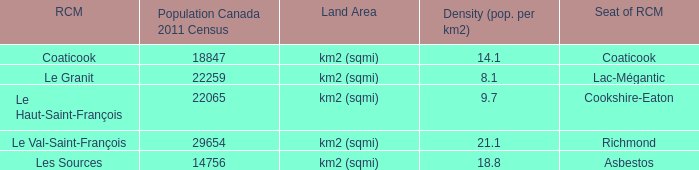What is the seat of the RCM in the county that has a density of 9.7? Cookshire-Eaton. 